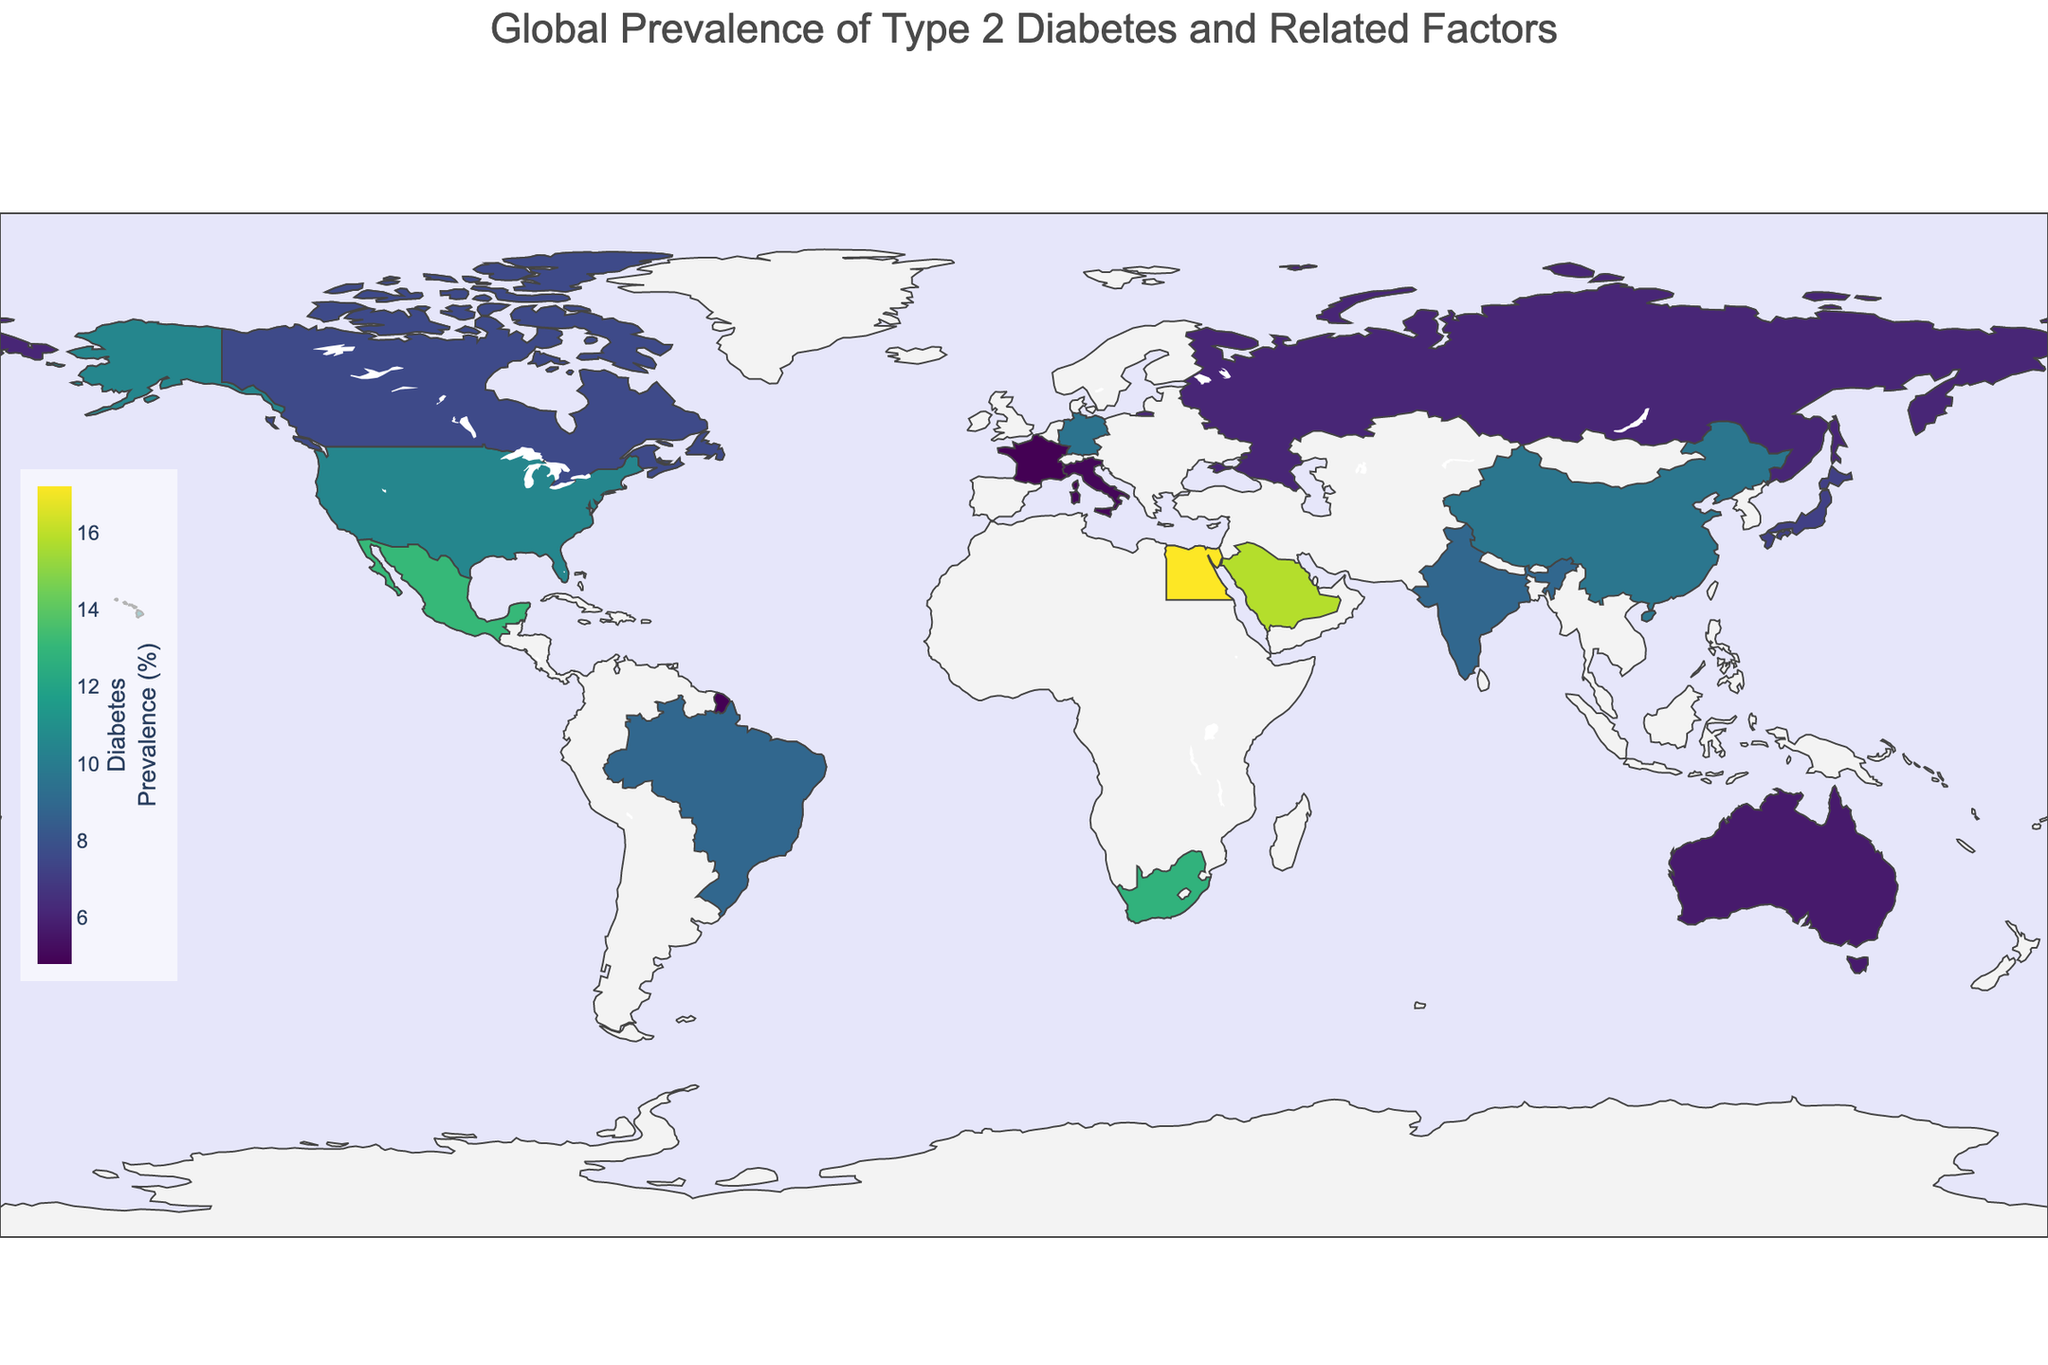Which country has the highest prevalence of type 2 diabetes? Look at the map and determine which country is shaded the darkest, indicating the highest prevalence of diabetes. According to the data provided, Egypt has the highest prevalence at 17.2%.
Answer: Egypt What is the relationship between carbohydrate consumption and diabetes prevalence for Japan and Mexico? Compare the carbohydrate consumption and diabetes prevalence of Japan and Mexico from the figure. Japan has a carb consumption of 435g and a diabetes prevalence of 7.2%, whereas Mexico has a carb consumption of 355g and a diabetes prevalence of 13.1%.
Answer: Mexico has lower carbohydrate consumption but higher diabetes prevalence compared to Japan Which country has the lowest obesity rate, and what is its diabetes prevalence? Identify the country with the lightest shading in the obesity rate data from the hover information on the map. India has the lowest obesity rate at 3.9%. By checking the diabetes prevalence data, India has a prevalence of 8.9%.
Answer: India, 8.9% Is there a correlation between vegetable consumption and diabetes prevalence in the countries provided? Check the visual data points for vegetable consumption and see their corresponding diabetes prevalence. Countries with higher vegetable consumption like China (3.7) and Japan (3.5) tend to have lower to moderate diabetes prevalence compared to countries with lower vegetable consumption like Saudi Arabia (1.9) and Egypt (2.9).
Answer: Higher vegetable consumption generally correlates with lower diabetes prevalence Which countries have a diabetes prevalence higher than 10%, and what are their carbohydrate consumption values? Look at the map for countries with diabetes prevalence above 10% and note their carbohydrate consumption values. The relevant countries are the United States (310g), Mexico (355g), Egypt (350g), Saudi Arabia (290g), and South Africa (260g).
Answer: United States (310g), Mexico (355g), Egypt (350g), Saudi Arabia (290g), South Africa (260g) How does the obesity rate in France compare to that in the United States? From the hover information, check the obesity rates for both France and the United States. France has an obesity rate of 21.6%, while the United States has an obesity rate of 36.2%.
Answer: The obesity rate in France is lower than in the United States What is the average vegetable consumption among countries with less than 7% diabetes prevalence? First, identify countries with diabetes prevalence less than 7%: Japan, Australia, Russia, and France. Then, average their vegetable consumption values: (3.5 + 2.7 + 2.8 + 3.1) / 4 = 3.025.
Answer: 3.03 